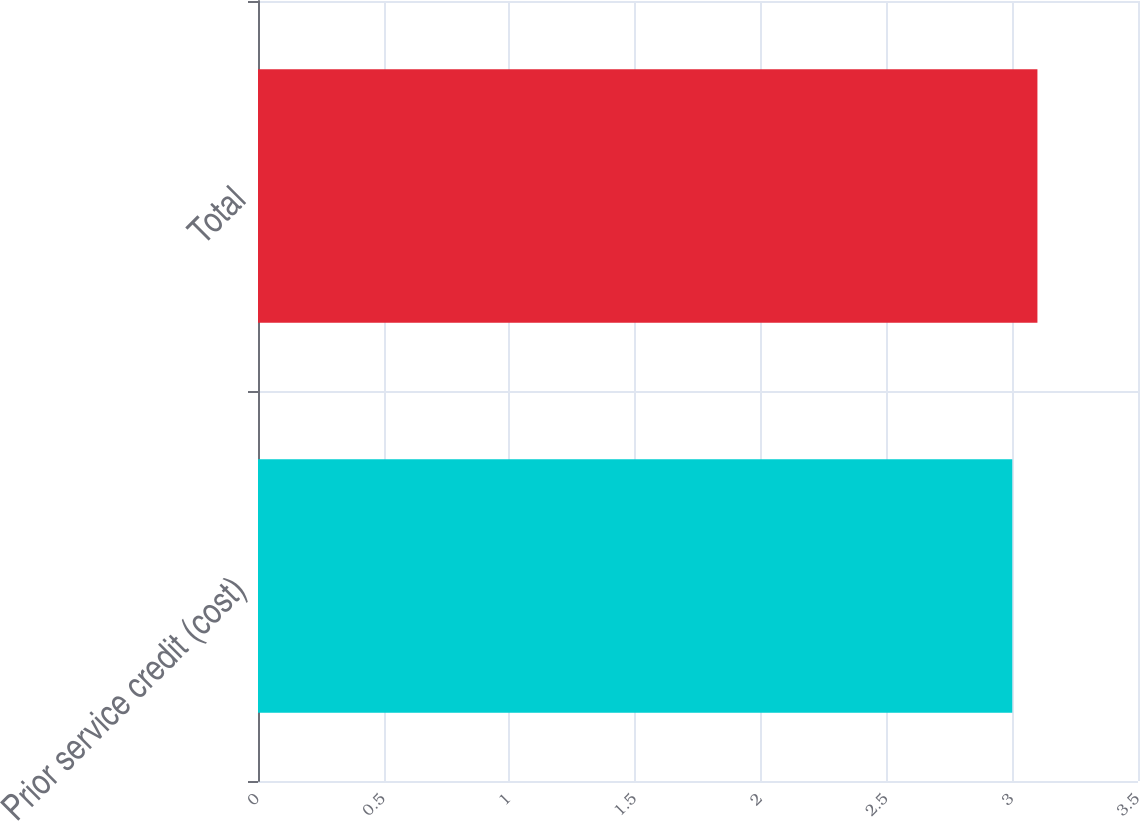<chart> <loc_0><loc_0><loc_500><loc_500><bar_chart><fcel>Prior service credit (cost)<fcel>Total<nl><fcel>3<fcel>3.1<nl></chart> 